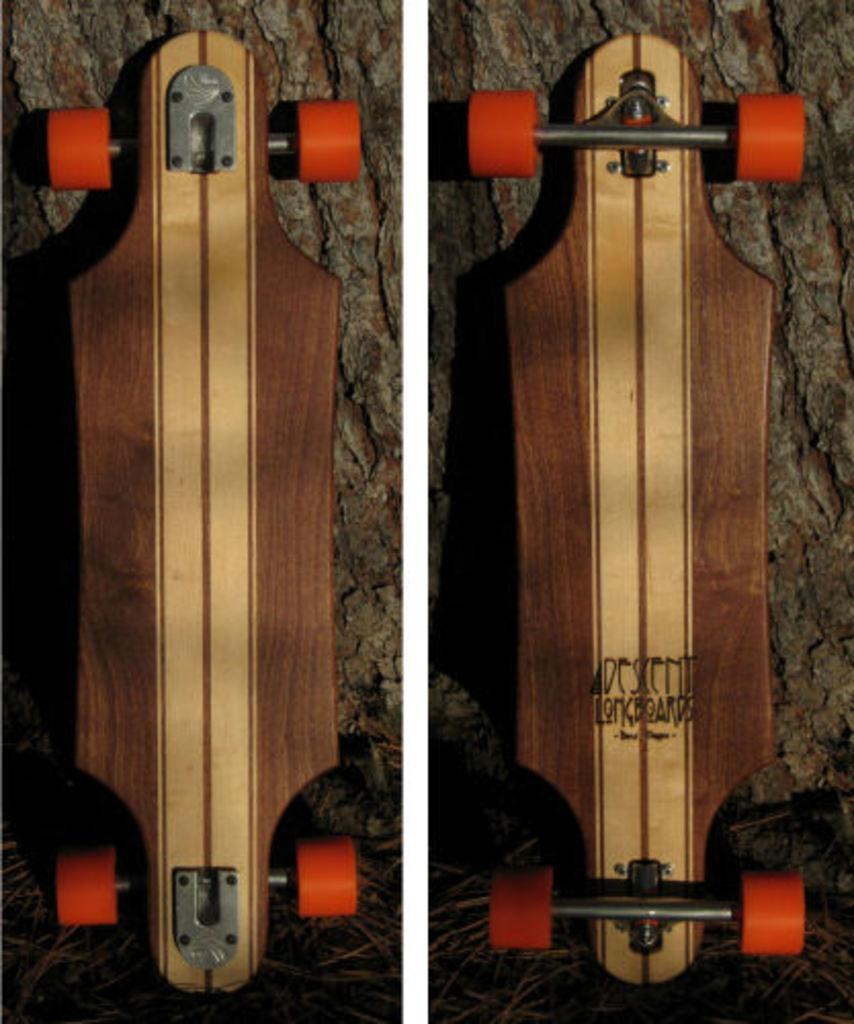What type of artwork is depicted in the image? The image is a collage. What objects are featured in the collage? There are skateboards in the image. What is the skateboards resting on in the collage? The skateboards are on a wooden object. What type of rod can be seen in the image? There is no rod present in the image. What view is depicted in the image? The image is a collage, so it does not depict a specific view or scene. 